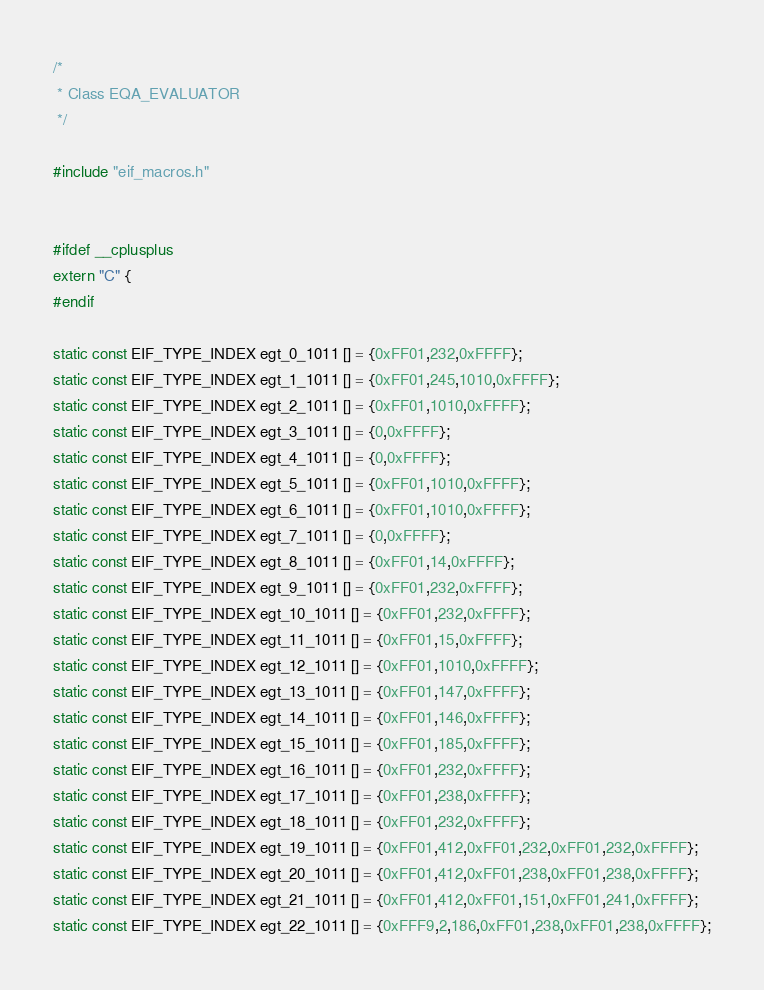<code> <loc_0><loc_0><loc_500><loc_500><_C_>/*
 * Class EQA_EVALUATOR
 */

#include "eif_macros.h"


#ifdef __cplusplus
extern "C" {
#endif

static const EIF_TYPE_INDEX egt_0_1011 [] = {0xFF01,232,0xFFFF};
static const EIF_TYPE_INDEX egt_1_1011 [] = {0xFF01,245,1010,0xFFFF};
static const EIF_TYPE_INDEX egt_2_1011 [] = {0xFF01,1010,0xFFFF};
static const EIF_TYPE_INDEX egt_3_1011 [] = {0,0xFFFF};
static const EIF_TYPE_INDEX egt_4_1011 [] = {0,0xFFFF};
static const EIF_TYPE_INDEX egt_5_1011 [] = {0xFF01,1010,0xFFFF};
static const EIF_TYPE_INDEX egt_6_1011 [] = {0xFF01,1010,0xFFFF};
static const EIF_TYPE_INDEX egt_7_1011 [] = {0,0xFFFF};
static const EIF_TYPE_INDEX egt_8_1011 [] = {0xFF01,14,0xFFFF};
static const EIF_TYPE_INDEX egt_9_1011 [] = {0xFF01,232,0xFFFF};
static const EIF_TYPE_INDEX egt_10_1011 [] = {0xFF01,232,0xFFFF};
static const EIF_TYPE_INDEX egt_11_1011 [] = {0xFF01,15,0xFFFF};
static const EIF_TYPE_INDEX egt_12_1011 [] = {0xFF01,1010,0xFFFF};
static const EIF_TYPE_INDEX egt_13_1011 [] = {0xFF01,147,0xFFFF};
static const EIF_TYPE_INDEX egt_14_1011 [] = {0xFF01,146,0xFFFF};
static const EIF_TYPE_INDEX egt_15_1011 [] = {0xFF01,185,0xFFFF};
static const EIF_TYPE_INDEX egt_16_1011 [] = {0xFF01,232,0xFFFF};
static const EIF_TYPE_INDEX egt_17_1011 [] = {0xFF01,238,0xFFFF};
static const EIF_TYPE_INDEX egt_18_1011 [] = {0xFF01,232,0xFFFF};
static const EIF_TYPE_INDEX egt_19_1011 [] = {0xFF01,412,0xFF01,232,0xFF01,232,0xFFFF};
static const EIF_TYPE_INDEX egt_20_1011 [] = {0xFF01,412,0xFF01,238,0xFF01,238,0xFFFF};
static const EIF_TYPE_INDEX egt_21_1011 [] = {0xFF01,412,0xFF01,151,0xFF01,241,0xFFFF};
static const EIF_TYPE_INDEX egt_22_1011 [] = {0xFFF9,2,186,0xFF01,238,0xFF01,238,0xFFFF};</code> 